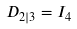Convert formula to latex. <formula><loc_0><loc_0><loc_500><loc_500>D _ { 2 | 3 } = I _ { 4 }</formula> 